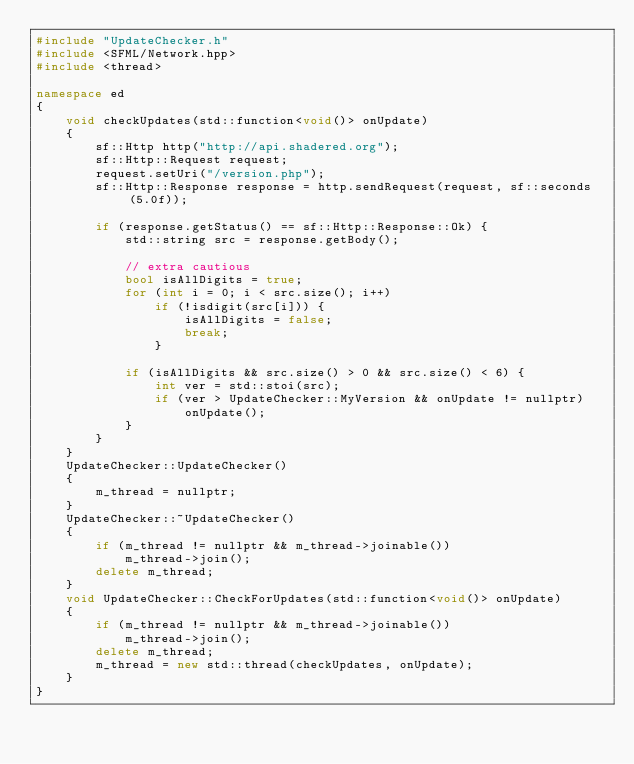<code> <loc_0><loc_0><loc_500><loc_500><_C++_>#include "UpdateChecker.h"
#include <SFML/Network.hpp>
#include <thread>

namespace ed
{
	void checkUpdates(std::function<void()> onUpdate)
	{
		sf::Http http("http://api.shadered.org");
		sf::Http::Request request;
		request.setUri("/version.php");
		sf::Http::Response response = http.sendRequest(request, sf::seconds(5.0f));

		if (response.getStatus() == sf::Http::Response::Ok) {
			std::string src = response.getBody();

			// extra cautious
			bool isAllDigits = true;
			for (int i = 0; i < src.size(); i++)
				if (!isdigit(src[i])) {
					isAllDigits = false;
					break;
				}

			if (isAllDigits && src.size() > 0 && src.size() < 6) {
				int ver = std::stoi(src);
				if (ver > UpdateChecker::MyVersion && onUpdate != nullptr) 
					onUpdate();
			}
		}
	}
	UpdateChecker::UpdateChecker()
	{
		m_thread = nullptr;
	}
	UpdateChecker::~UpdateChecker()
	{
		if (m_thread != nullptr && m_thread->joinable())
			m_thread->join();
		delete m_thread;
	}
	void UpdateChecker::CheckForUpdates(std::function<void()> onUpdate)
	{
		if (m_thread != nullptr && m_thread->joinable())
			m_thread->join();
		delete m_thread;
		m_thread = new std::thread(checkUpdates, onUpdate);
	}
}</code> 